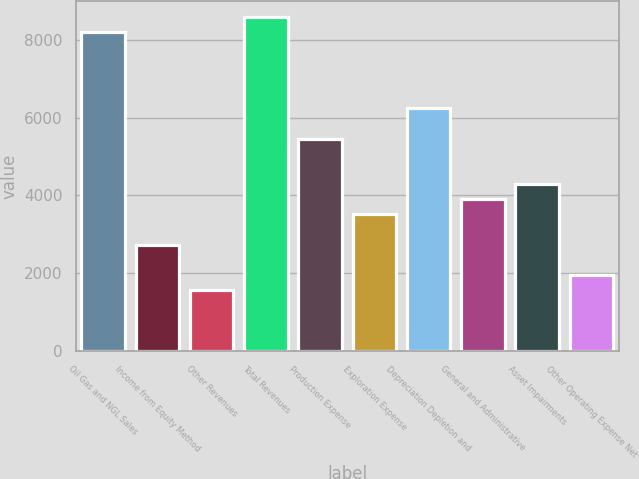<chart> <loc_0><loc_0><loc_500><loc_500><bar_chart><fcel>Oil Gas and NGL Sales<fcel>Income from Equity Method<fcel>Other Revenues<fcel>Total Revenues<fcel>Production Expense<fcel>Exploration Expense<fcel>Depreciation Depletion and<fcel>General and Administrative<fcel>Asset Impairments<fcel>Other Operating Expense Net<nl><fcel>8183.72<fcel>2732.96<fcel>1564.94<fcel>8573.06<fcel>5458.34<fcel>3511.64<fcel>6237.02<fcel>3900.98<fcel>4290.32<fcel>1954.28<nl></chart> 